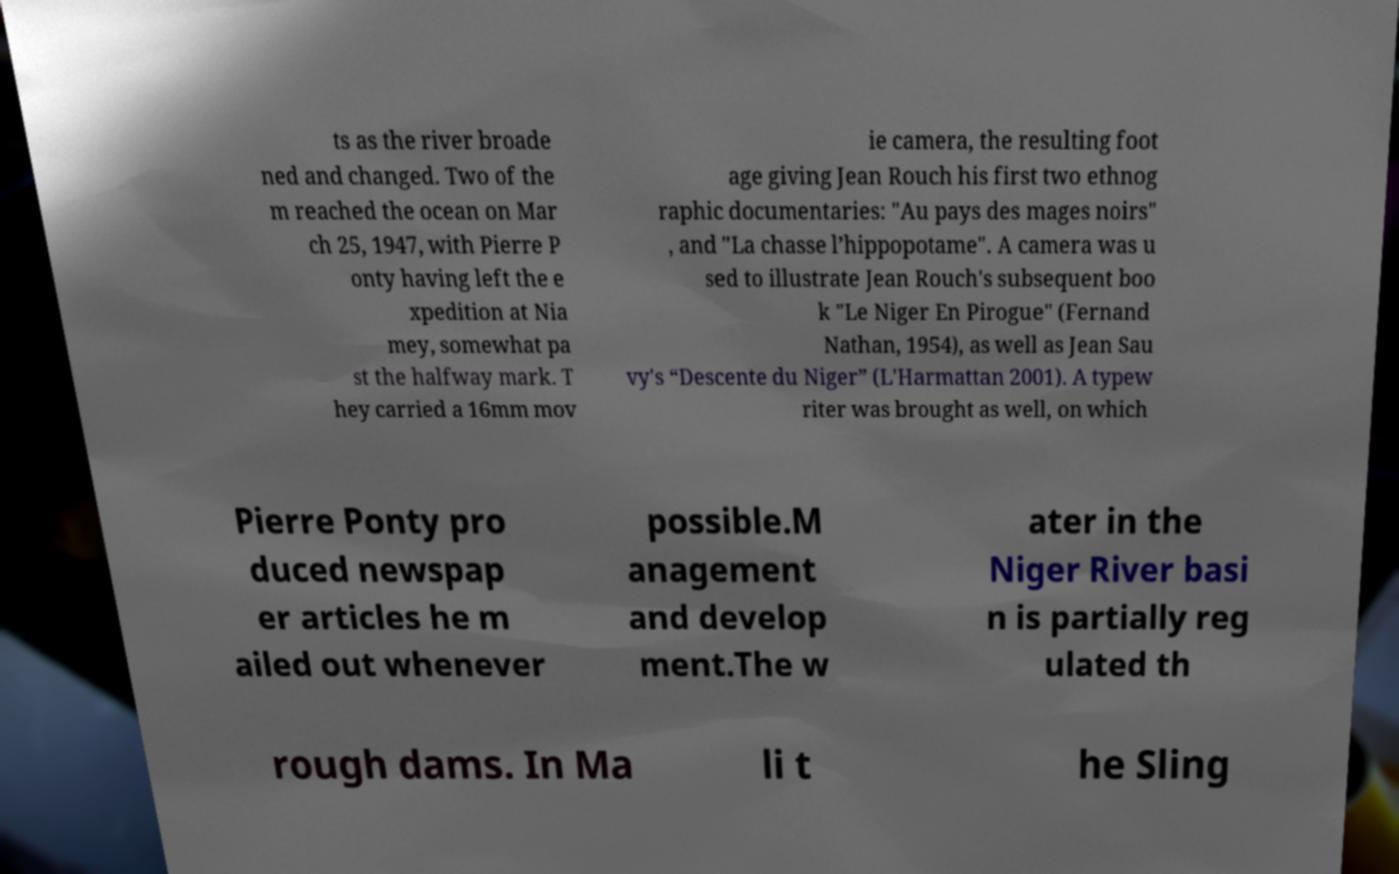What messages or text are displayed in this image? I need them in a readable, typed format. ts as the river broade ned and changed. Two of the m reached the ocean on Mar ch 25, 1947, with Pierre P onty having left the e xpedition at Nia mey, somewhat pa st the halfway mark. T hey carried a 16mm mov ie camera, the resulting foot age giving Jean Rouch his first two ethnog raphic documentaries: "Au pays des mages noirs" , and "La chasse l’hippopotame". A camera was u sed to illustrate Jean Rouch's subsequent boo k "Le Niger En Pirogue" (Fernand Nathan, 1954), as well as Jean Sau vy's “Descente du Niger” (L'Harmattan 2001). A typew riter was brought as well, on which Pierre Ponty pro duced newspap er articles he m ailed out whenever possible.M anagement and develop ment.The w ater in the Niger River basi n is partially reg ulated th rough dams. In Ma li t he Sling 